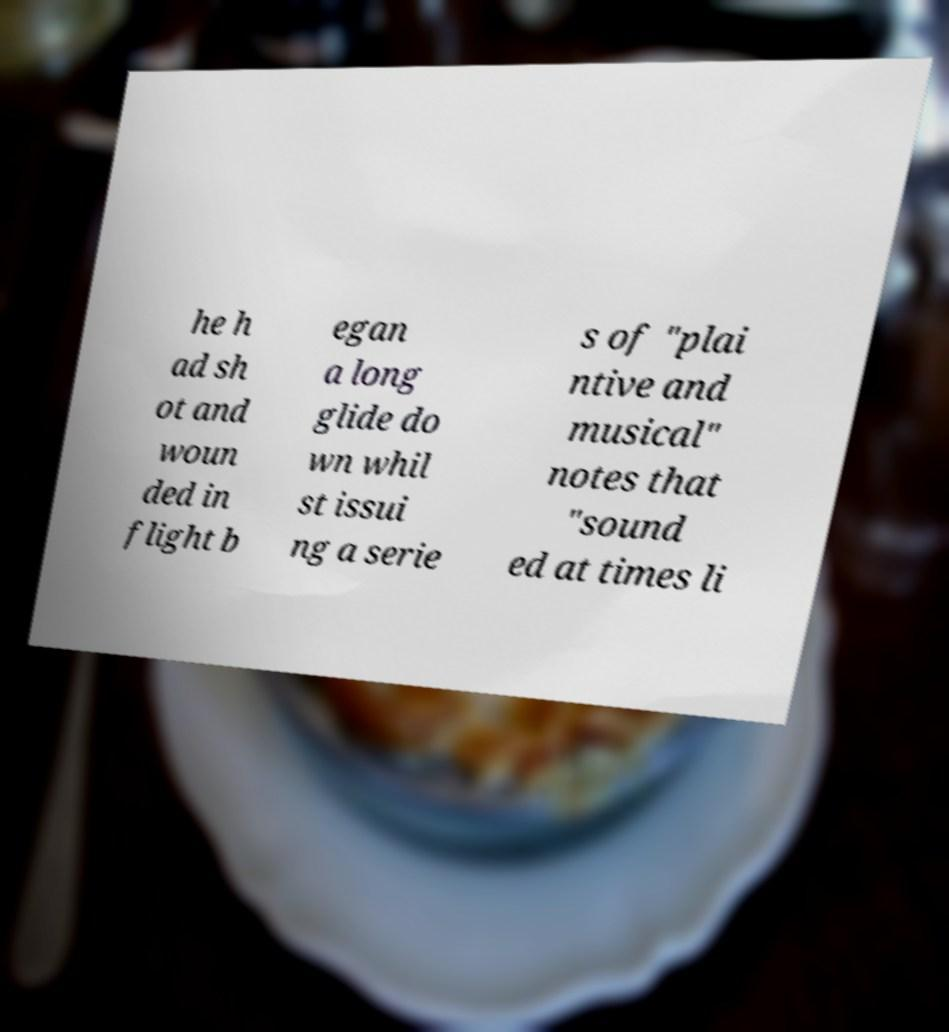For documentation purposes, I need the text within this image transcribed. Could you provide that? he h ad sh ot and woun ded in flight b egan a long glide do wn whil st issui ng a serie s of "plai ntive and musical" notes that "sound ed at times li 